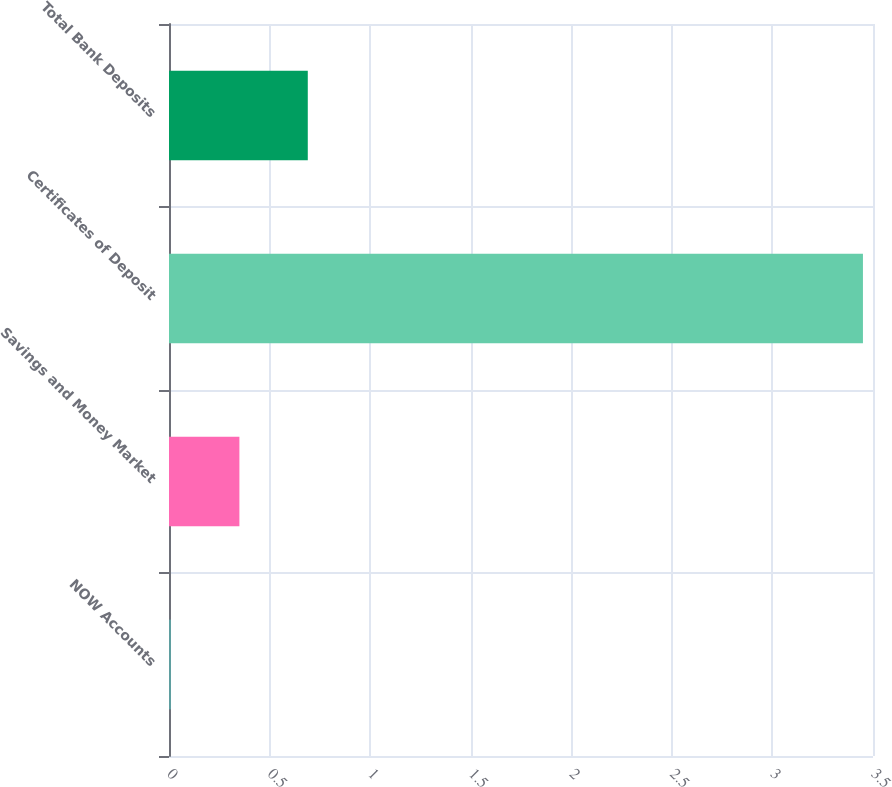Convert chart. <chart><loc_0><loc_0><loc_500><loc_500><bar_chart><fcel>NOW Accounts<fcel>Savings and Money Market<fcel>Certificates of Deposit<fcel>Total Bank Deposits<nl><fcel>0.01<fcel>0.35<fcel>3.45<fcel>0.69<nl></chart> 